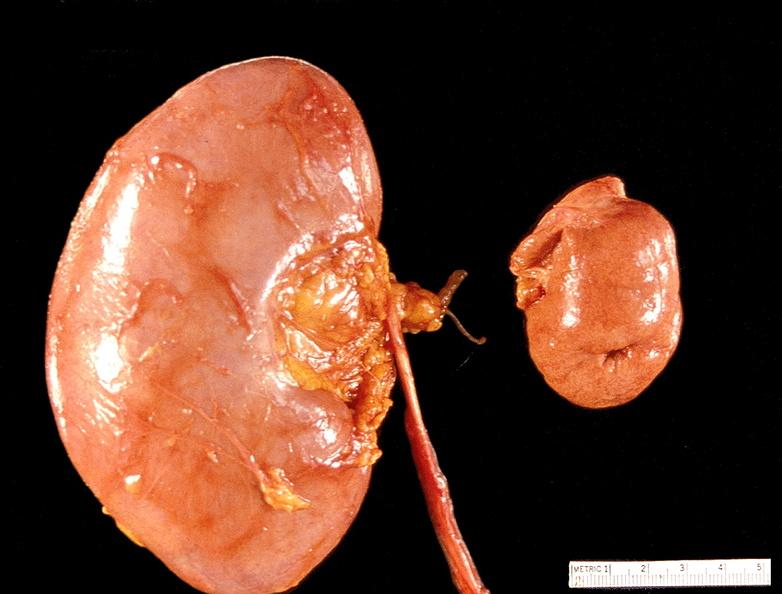does conjoined twins show kidney, hypoplasia and compensatory hypertrophy 300 grams left?
Answer the question using a single word or phrase. No 